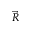<formula> <loc_0><loc_0><loc_500><loc_500>\vec { R }</formula> 